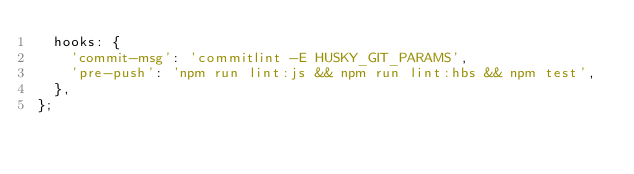Convert code to text. <code><loc_0><loc_0><loc_500><loc_500><_JavaScript_>  hooks: {
    'commit-msg': 'commitlint -E HUSKY_GIT_PARAMS',
    'pre-push': 'npm run lint:js && npm run lint:hbs && npm test',
  },
};
</code> 